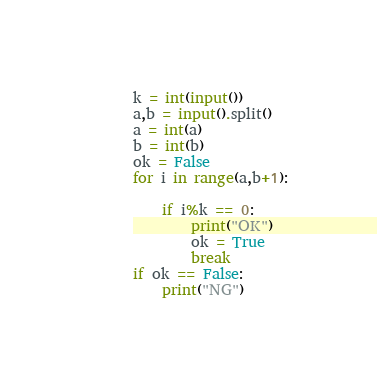Convert code to text. <code><loc_0><loc_0><loc_500><loc_500><_Python_>k = int(input())
a,b = input().split()
a = int(a)
b = int(b)
ok = False
for i in range(a,b+1):

    if i%k == 0:
        print("OK")
        ok = True
        break
if ok == False:
    print("NG")</code> 